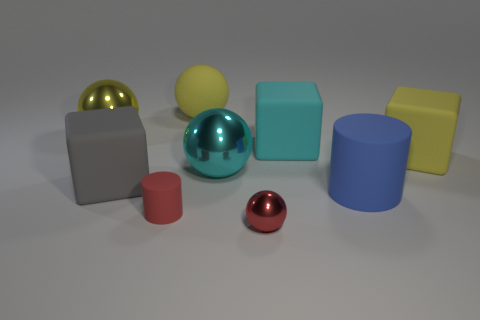Subtract all big cyan blocks. How many blocks are left? 2 Subtract all cyan balls. How many balls are left? 3 Subtract all cyan spheres. How many yellow cylinders are left? 0 Add 1 purple matte cylinders. How many objects exist? 10 Subtract 3 spheres. How many spheres are left? 1 Add 4 red matte objects. How many red matte objects exist? 5 Subtract 1 blue cylinders. How many objects are left? 8 Subtract all cylinders. How many objects are left? 7 Subtract all yellow blocks. Subtract all purple spheres. How many blocks are left? 2 Subtract all big yellow metallic things. Subtract all brown cubes. How many objects are left? 8 